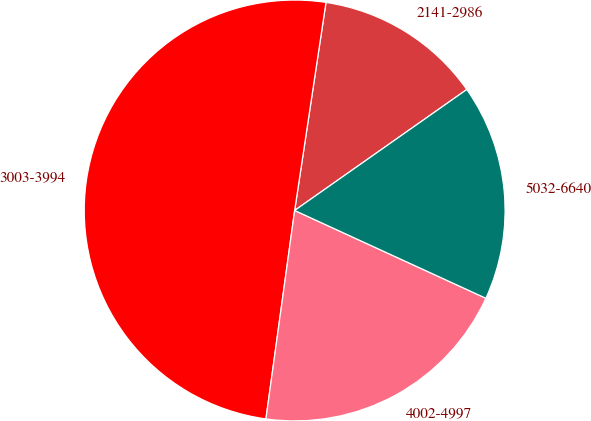Convert chart to OTSL. <chart><loc_0><loc_0><loc_500><loc_500><pie_chart><fcel>2141-2986<fcel>3003-3994<fcel>4002-4997<fcel>5032-6640<nl><fcel>12.87%<fcel>50.2%<fcel>20.33%<fcel>16.6%<nl></chart> 